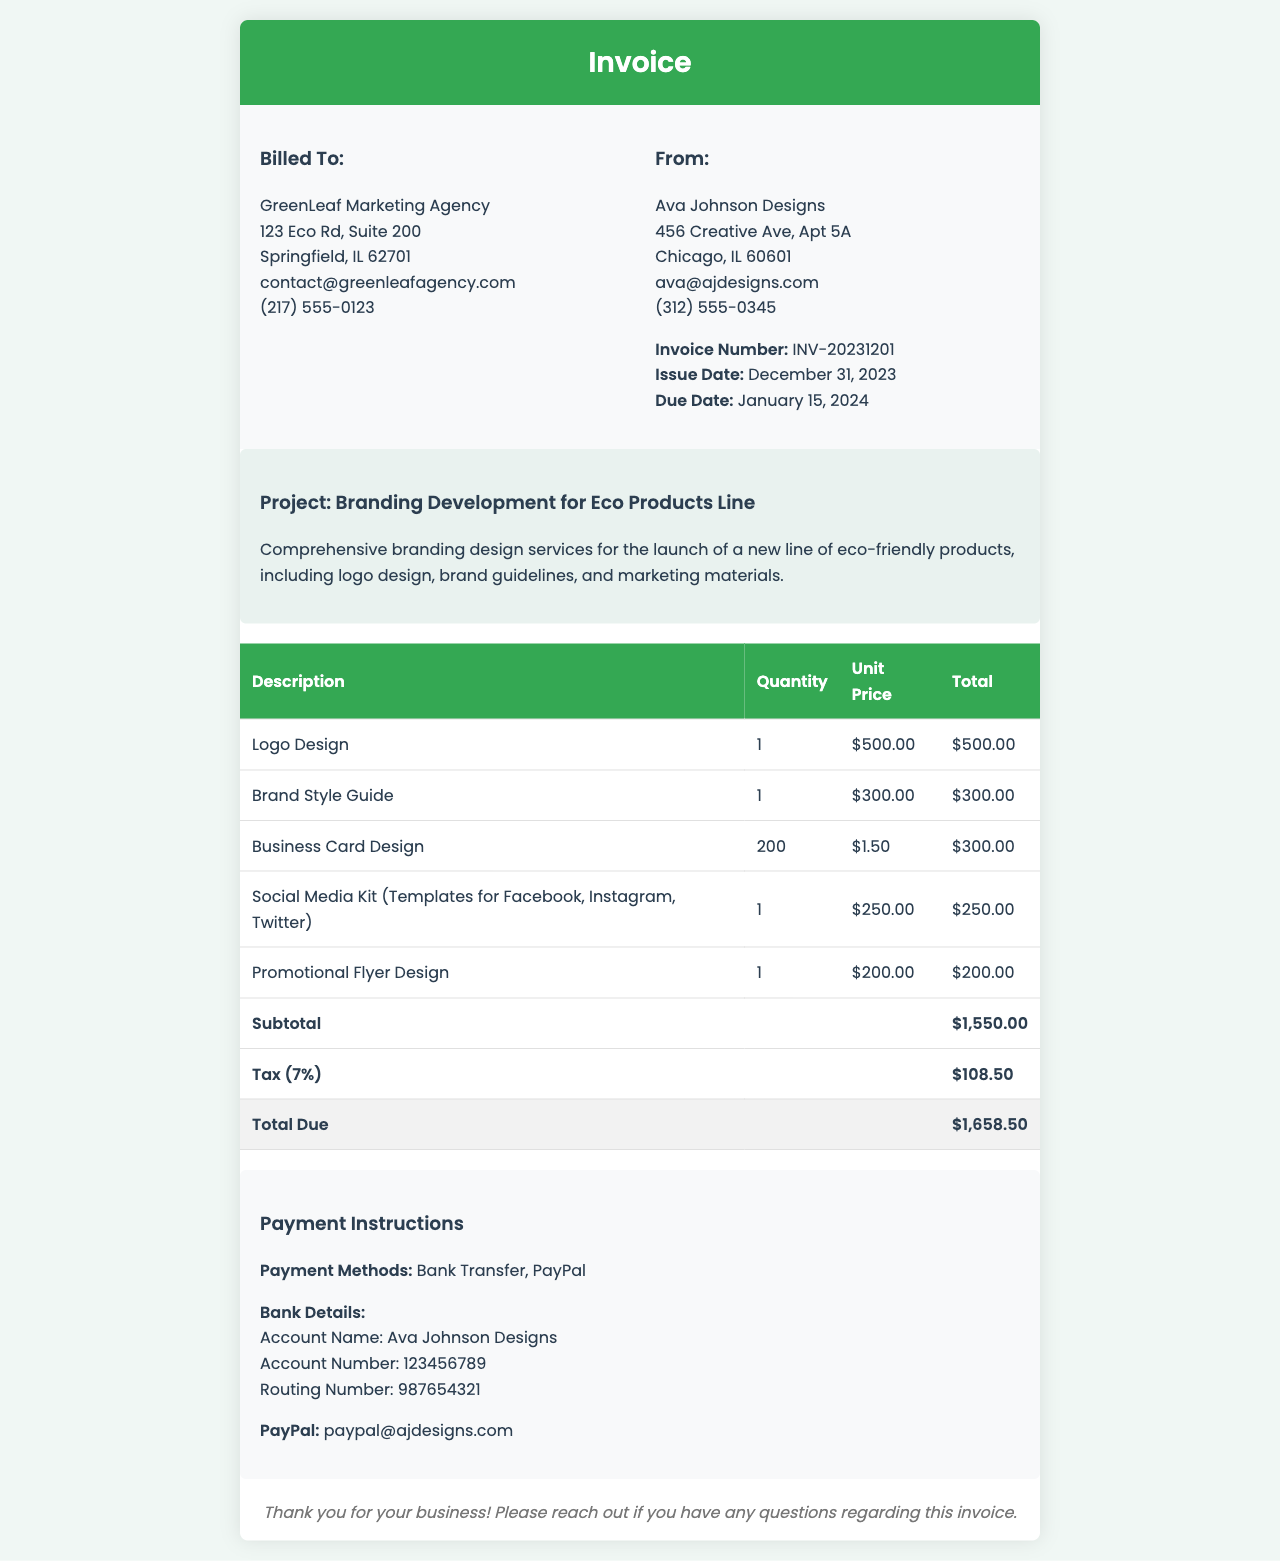what is the invoice number? The invoice number is prominently displayed in the document, specifically listed under the "From" section.
Answer: INV-20231201 what is the due date for the invoice? The due date is listed in the "From" section under the invoice details.
Answer: January 15, 2024 who is billed to? The "Billed To" section provides the name and address of the client receiving the invoice.
Answer: GreenLeaf Marketing Agency what is the total amount due? The total amount due is indicated in the "Total Due" row at the bottom of the invoice table.
Answer: $1,658.50 how many business cards were designed? The quantity of business cards is noted in the corresponding row within the invoice table.
Answer: 200 what project is this invoice for? The project name is stated in the "Project" heading under project details.
Answer: Branding Development for Eco Products Line what is the subtotal amount? The subtotal is provided in the row labeled "Subtotal" in the invoice table.
Answer: $1,550.00 which payment methods are accepted? The payment methods are listed in the "Payment Instructions" section of the invoice.
Answer: Bank Transfer, PayPal 